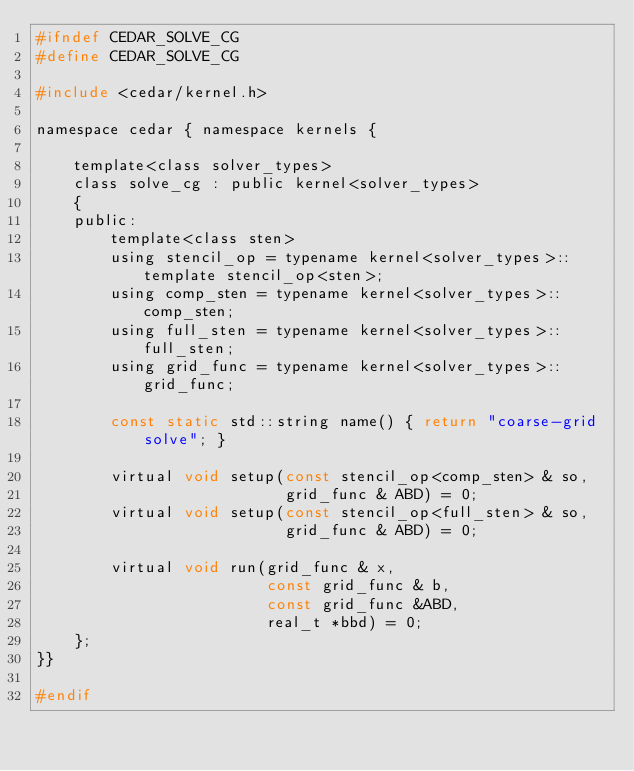Convert code to text. <code><loc_0><loc_0><loc_500><loc_500><_C_>#ifndef CEDAR_SOLVE_CG
#define CEDAR_SOLVE_CG

#include <cedar/kernel.h>

namespace cedar { namespace kernels {

	template<class solver_types>
	class solve_cg : public kernel<solver_types>
	{
	public:
		template<class sten>
		using stencil_op = typename kernel<solver_types>::template stencil_op<sten>;
		using comp_sten = typename kernel<solver_types>::comp_sten;
		using full_sten = typename kernel<solver_types>::full_sten;
		using grid_func = typename kernel<solver_types>::grid_func;

		const static std::string name() { return "coarse-grid solve"; }

		virtual void setup(const stencil_op<comp_sten> & so,
		                   grid_func & ABD) = 0;
		virtual void setup(const stencil_op<full_sten> & so,
		                   grid_func & ABD) = 0;

		virtual void run(grid_func & x,
		                 const grid_func & b,
		                 const grid_func &ABD,
		                 real_t *bbd) = 0;
	};
}}

#endif
</code> 